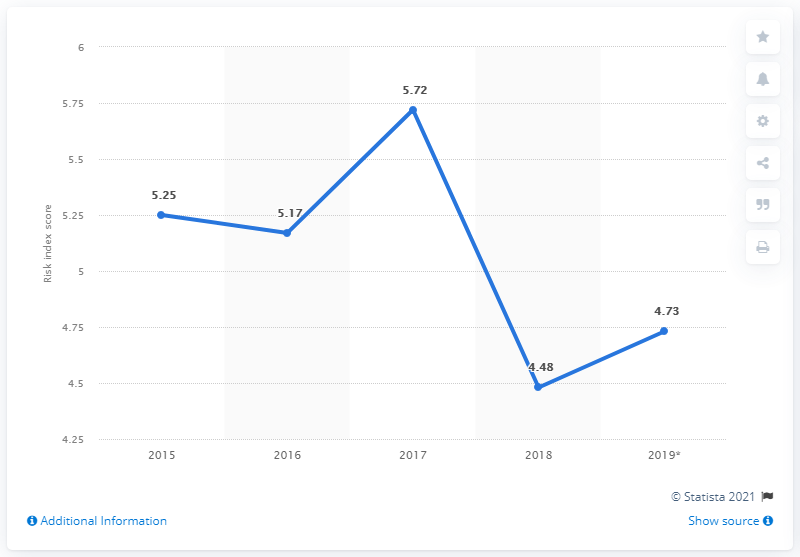Identify some key points in this picture. In 2019, St. Lucia's index score was 4.73. 